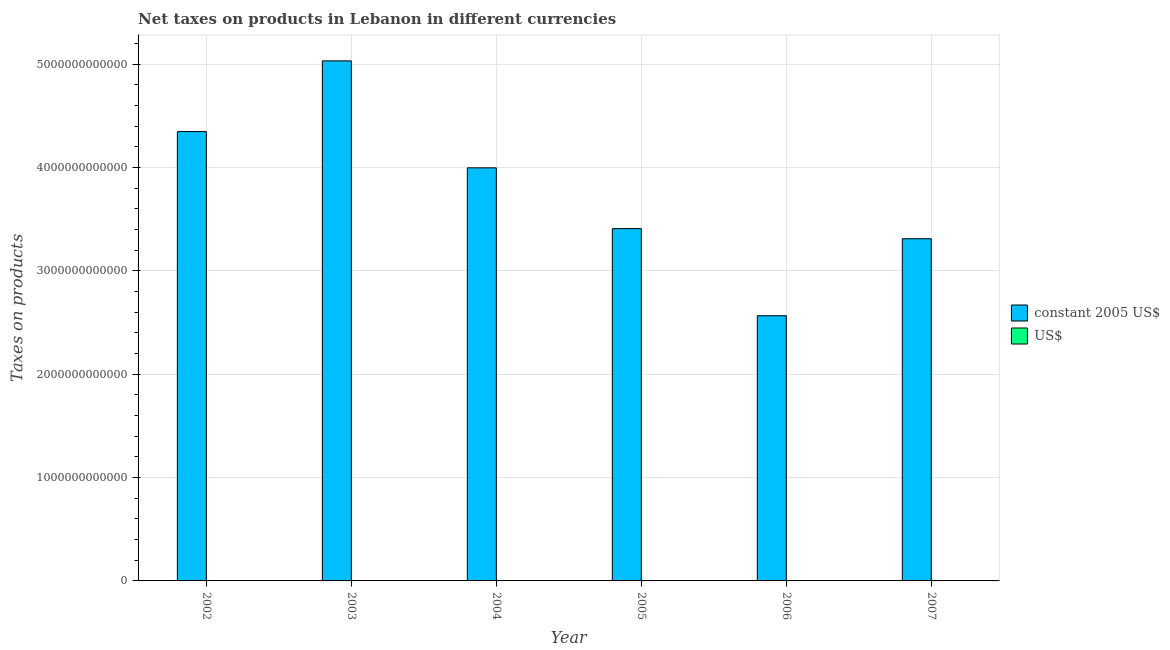Are the number of bars on each tick of the X-axis equal?
Ensure brevity in your answer.  Yes. How many bars are there on the 2nd tick from the left?
Make the answer very short. 2. What is the net taxes in us$ in 2004?
Ensure brevity in your answer.  2.65e+09. Across all years, what is the maximum net taxes in constant 2005 us$?
Give a very brief answer. 5.03e+12. Across all years, what is the minimum net taxes in us$?
Provide a succinct answer. 1.70e+09. In which year was the net taxes in us$ maximum?
Your response must be concise. 2003. What is the total net taxes in us$ in the graph?
Your response must be concise. 1.50e+1. What is the difference between the net taxes in constant 2005 us$ in 2002 and that in 2006?
Your answer should be very brief. 1.78e+12. What is the difference between the net taxes in constant 2005 us$ in 2005 and the net taxes in us$ in 2004?
Offer a very short reply. -5.88e+11. What is the average net taxes in constant 2005 us$ per year?
Your answer should be very brief. 3.78e+12. In the year 2006, what is the difference between the net taxes in constant 2005 us$ and net taxes in us$?
Offer a very short reply. 0. What is the ratio of the net taxes in constant 2005 us$ in 2003 to that in 2007?
Offer a terse response. 1.52. Is the difference between the net taxes in constant 2005 us$ in 2003 and 2007 greater than the difference between the net taxes in us$ in 2003 and 2007?
Your response must be concise. No. What is the difference between the highest and the second highest net taxes in constant 2005 us$?
Provide a short and direct response. 6.84e+11. What is the difference between the highest and the lowest net taxes in us$?
Provide a short and direct response. 1.64e+09. Is the sum of the net taxes in us$ in 2004 and 2006 greater than the maximum net taxes in constant 2005 us$ across all years?
Keep it short and to the point. Yes. What does the 2nd bar from the left in 2002 represents?
Offer a very short reply. US$. What does the 1st bar from the right in 2004 represents?
Your answer should be very brief. US$. Are all the bars in the graph horizontal?
Make the answer very short. No. What is the difference between two consecutive major ticks on the Y-axis?
Give a very brief answer. 1.00e+12. Does the graph contain grids?
Give a very brief answer. Yes. Where does the legend appear in the graph?
Provide a short and direct response. Center right. How are the legend labels stacked?
Your answer should be very brief. Vertical. What is the title of the graph?
Your response must be concise. Net taxes on products in Lebanon in different currencies. What is the label or title of the X-axis?
Offer a very short reply. Year. What is the label or title of the Y-axis?
Offer a very short reply. Taxes on products. What is the Taxes on products of constant 2005 US$ in 2002?
Keep it short and to the point. 4.35e+12. What is the Taxes on products in US$ in 2002?
Your answer should be very brief. 2.88e+09. What is the Taxes on products of constant 2005 US$ in 2003?
Your answer should be very brief. 5.03e+12. What is the Taxes on products in US$ in 2003?
Offer a very short reply. 3.34e+09. What is the Taxes on products in constant 2005 US$ in 2004?
Offer a very short reply. 4.00e+12. What is the Taxes on products in US$ in 2004?
Provide a short and direct response. 2.65e+09. What is the Taxes on products of constant 2005 US$ in 2005?
Give a very brief answer. 3.41e+12. What is the Taxes on products in US$ in 2005?
Offer a very short reply. 2.26e+09. What is the Taxes on products of constant 2005 US$ in 2006?
Provide a succinct answer. 2.57e+12. What is the Taxes on products in US$ in 2006?
Provide a succinct answer. 1.70e+09. What is the Taxes on products of constant 2005 US$ in 2007?
Provide a succinct answer. 3.31e+12. What is the Taxes on products of US$ in 2007?
Your answer should be compact. 2.20e+09. Across all years, what is the maximum Taxes on products in constant 2005 US$?
Your answer should be compact. 5.03e+12. Across all years, what is the maximum Taxes on products in US$?
Make the answer very short. 3.34e+09. Across all years, what is the minimum Taxes on products in constant 2005 US$?
Provide a short and direct response. 2.57e+12. Across all years, what is the minimum Taxes on products in US$?
Provide a short and direct response. 1.70e+09. What is the total Taxes on products in constant 2005 US$ in the graph?
Offer a very short reply. 2.27e+13. What is the total Taxes on products of US$ in the graph?
Make the answer very short. 1.50e+1. What is the difference between the Taxes on products of constant 2005 US$ in 2002 and that in 2003?
Ensure brevity in your answer.  -6.84e+11. What is the difference between the Taxes on products in US$ in 2002 and that in 2003?
Keep it short and to the point. -4.54e+08. What is the difference between the Taxes on products in constant 2005 US$ in 2002 and that in 2004?
Give a very brief answer. 3.51e+11. What is the difference between the Taxes on products in US$ in 2002 and that in 2004?
Give a very brief answer. 2.33e+08. What is the difference between the Taxes on products in constant 2005 US$ in 2002 and that in 2005?
Give a very brief answer. 9.39e+11. What is the difference between the Taxes on products in US$ in 2002 and that in 2005?
Offer a very short reply. 6.23e+08. What is the difference between the Taxes on products in constant 2005 US$ in 2002 and that in 2006?
Your answer should be very brief. 1.78e+12. What is the difference between the Taxes on products in US$ in 2002 and that in 2006?
Keep it short and to the point. 1.18e+09. What is the difference between the Taxes on products of constant 2005 US$ in 2002 and that in 2007?
Offer a very short reply. 1.04e+12. What is the difference between the Taxes on products in US$ in 2002 and that in 2007?
Your response must be concise. 6.88e+08. What is the difference between the Taxes on products of constant 2005 US$ in 2003 and that in 2004?
Offer a very short reply. 1.04e+12. What is the difference between the Taxes on products of US$ in 2003 and that in 2004?
Keep it short and to the point. 6.87e+08. What is the difference between the Taxes on products of constant 2005 US$ in 2003 and that in 2005?
Provide a succinct answer. 1.62e+12. What is the difference between the Taxes on products in US$ in 2003 and that in 2005?
Offer a terse response. 1.08e+09. What is the difference between the Taxes on products of constant 2005 US$ in 2003 and that in 2006?
Make the answer very short. 2.47e+12. What is the difference between the Taxes on products in US$ in 2003 and that in 2006?
Offer a terse response. 1.64e+09. What is the difference between the Taxes on products of constant 2005 US$ in 2003 and that in 2007?
Give a very brief answer. 1.72e+12. What is the difference between the Taxes on products in US$ in 2003 and that in 2007?
Offer a very short reply. 1.14e+09. What is the difference between the Taxes on products of constant 2005 US$ in 2004 and that in 2005?
Offer a terse response. 5.88e+11. What is the difference between the Taxes on products of US$ in 2004 and that in 2005?
Offer a very short reply. 3.90e+08. What is the difference between the Taxes on products of constant 2005 US$ in 2004 and that in 2006?
Ensure brevity in your answer.  1.43e+12. What is the difference between the Taxes on products of US$ in 2004 and that in 2006?
Make the answer very short. 9.49e+08. What is the difference between the Taxes on products in constant 2005 US$ in 2004 and that in 2007?
Keep it short and to the point. 6.86e+11. What is the difference between the Taxes on products of US$ in 2004 and that in 2007?
Provide a short and direct response. 4.55e+08. What is the difference between the Taxes on products of constant 2005 US$ in 2005 and that in 2006?
Make the answer very short. 8.43e+11. What is the difference between the Taxes on products of US$ in 2005 and that in 2006?
Provide a short and direct response. 5.59e+08. What is the difference between the Taxes on products of constant 2005 US$ in 2005 and that in 2007?
Your answer should be compact. 9.80e+1. What is the difference between the Taxes on products in US$ in 2005 and that in 2007?
Offer a terse response. 6.50e+07. What is the difference between the Taxes on products of constant 2005 US$ in 2006 and that in 2007?
Your answer should be very brief. -7.45e+11. What is the difference between the Taxes on products of US$ in 2006 and that in 2007?
Your answer should be compact. -4.94e+08. What is the difference between the Taxes on products in constant 2005 US$ in 2002 and the Taxes on products in US$ in 2003?
Provide a succinct answer. 4.34e+12. What is the difference between the Taxes on products in constant 2005 US$ in 2002 and the Taxes on products in US$ in 2004?
Offer a terse response. 4.35e+12. What is the difference between the Taxes on products in constant 2005 US$ in 2002 and the Taxes on products in US$ in 2005?
Provide a succinct answer. 4.35e+12. What is the difference between the Taxes on products of constant 2005 US$ in 2002 and the Taxes on products of US$ in 2006?
Make the answer very short. 4.35e+12. What is the difference between the Taxes on products in constant 2005 US$ in 2002 and the Taxes on products in US$ in 2007?
Offer a very short reply. 4.35e+12. What is the difference between the Taxes on products of constant 2005 US$ in 2003 and the Taxes on products of US$ in 2004?
Your response must be concise. 5.03e+12. What is the difference between the Taxes on products in constant 2005 US$ in 2003 and the Taxes on products in US$ in 2005?
Give a very brief answer. 5.03e+12. What is the difference between the Taxes on products in constant 2005 US$ in 2003 and the Taxes on products in US$ in 2006?
Offer a terse response. 5.03e+12. What is the difference between the Taxes on products of constant 2005 US$ in 2003 and the Taxes on products of US$ in 2007?
Your answer should be very brief. 5.03e+12. What is the difference between the Taxes on products of constant 2005 US$ in 2004 and the Taxes on products of US$ in 2005?
Your answer should be compact. 3.99e+12. What is the difference between the Taxes on products of constant 2005 US$ in 2004 and the Taxes on products of US$ in 2006?
Offer a very short reply. 4.00e+12. What is the difference between the Taxes on products of constant 2005 US$ in 2004 and the Taxes on products of US$ in 2007?
Your response must be concise. 3.99e+12. What is the difference between the Taxes on products in constant 2005 US$ in 2005 and the Taxes on products in US$ in 2006?
Make the answer very short. 3.41e+12. What is the difference between the Taxes on products of constant 2005 US$ in 2005 and the Taxes on products of US$ in 2007?
Ensure brevity in your answer.  3.41e+12. What is the difference between the Taxes on products of constant 2005 US$ in 2006 and the Taxes on products of US$ in 2007?
Ensure brevity in your answer.  2.56e+12. What is the average Taxes on products of constant 2005 US$ per year?
Offer a very short reply. 3.78e+12. What is the average Taxes on products of US$ per year?
Provide a succinct answer. 2.51e+09. In the year 2002, what is the difference between the Taxes on products in constant 2005 US$ and Taxes on products in US$?
Ensure brevity in your answer.  4.35e+12. In the year 2003, what is the difference between the Taxes on products of constant 2005 US$ and Taxes on products of US$?
Provide a short and direct response. 5.03e+12. In the year 2004, what is the difference between the Taxes on products of constant 2005 US$ and Taxes on products of US$?
Provide a short and direct response. 3.99e+12. In the year 2005, what is the difference between the Taxes on products in constant 2005 US$ and Taxes on products in US$?
Offer a very short reply. 3.41e+12. In the year 2006, what is the difference between the Taxes on products of constant 2005 US$ and Taxes on products of US$?
Provide a succinct answer. 2.56e+12. In the year 2007, what is the difference between the Taxes on products of constant 2005 US$ and Taxes on products of US$?
Your answer should be very brief. 3.31e+12. What is the ratio of the Taxes on products in constant 2005 US$ in 2002 to that in 2003?
Provide a short and direct response. 0.86. What is the ratio of the Taxes on products in US$ in 2002 to that in 2003?
Offer a very short reply. 0.86. What is the ratio of the Taxes on products of constant 2005 US$ in 2002 to that in 2004?
Your answer should be compact. 1.09. What is the ratio of the Taxes on products of US$ in 2002 to that in 2004?
Give a very brief answer. 1.09. What is the ratio of the Taxes on products of constant 2005 US$ in 2002 to that in 2005?
Give a very brief answer. 1.28. What is the ratio of the Taxes on products in US$ in 2002 to that in 2005?
Keep it short and to the point. 1.28. What is the ratio of the Taxes on products in constant 2005 US$ in 2002 to that in 2006?
Your answer should be very brief. 1.69. What is the ratio of the Taxes on products in US$ in 2002 to that in 2006?
Your response must be concise. 1.69. What is the ratio of the Taxes on products of constant 2005 US$ in 2002 to that in 2007?
Provide a succinct answer. 1.31. What is the ratio of the Taxes on products of US$ in 2002 to that in 2007?
Your answer should be very brief. 1.31. What is the ratio of the Taxes on products in constant 2005 US$ in 2003 to that in 2004?
Keep it short and to the point. 1.26. What is the ratio of the Taxes on products in US$ in 2003 to that in 2004?
Your answer should be compact. 1.26. What is the ratio of the Taxes on products in constant 2005 US$ in 2003 to that in 2005?
Your response must be concise. 1.48. What is the ratio of the Taxes on products in US$ in 2003 to that in 2005?
Ensure brevity in your answer.  1.48. What is the ratio of the Taxes on products of constant 2005 US$ in 2003 to that in 2006?
Your answer should be very brief. 1.96. What is the ratio of the Taxes on products in US$ in 2003 to that in 2006?
Give a very brief answer. 1.96. What is the ratio of the Taxes on products of constant 2005 US$ in 2003 to that in 2007?
Make the answer very short. 1.52. What is the ratio of the Taxes on products of US$ in 2003 to that in 2007?
Make the answer very short. 1.52. What is the ratio of the Taxes on products in constant 2005 US$ in 2004 to that in 2005?
Make the answer very short. 1.17. What is the ratio of the Taxes on products in US$ in 2004 to that in 2005?
Keep it short and to the point. 1.17. What is the ratio of the Taxes on products in constant 2005 US$ in 2004 to that in 2006?
Provide a short and direct response. 1.56. What is the ratio of the Taxes on products of US$ in 2004 to that in 2006?
Provide a short and direct response. 1.56. What is the ratio of the Taxes on products of constant 2005 US$ in 2004 to that in 2007?
Provide a short and direct response. 1.21. What is the ratio of the Taxes on products in US$ in 2004 to that in 2007?
Offer a very short reply. 1.21. What is the ratio of the Taxes on products in constant 2005 US$ in 2005 to that in 2006?
Provide a short and direct response. 1.33. What is the ratio of the Taxes on products in US$ in 2005 to that in 2006?
Offer a very short reply. 1.33. What is the ratio of the Taxes on products in constant 2005 US$ in 2005 to that in 2007?
Provide a succinct answer. 1.03. What is the ratio of the Taxes on products of US$ in 2005 to that in 2007?
Make the answer very short. 1.03. What is the ratio of the Taxes on products of constant 2005 US$ in 2006 to that in 2007?
Offer a very short reply. 0.78. What is the ratio of the Taxes on products in US$ in 2006 to that in 2007?
Ensure brevity in your answer.  0.78. What is the difference between the highest and the second highest Taxes on products in constant 2005 US$?
Make the answer very short. 6.84e+11. What is the difference between the highest and the second highest Taxes on products in US$?
Keep it short and to the point. 4.54e+08. What is the difference between the highest and the lowest Taxes on products in constant 2005 US$?
Provide a succinct answer. 2.47e+12. What is the difference between the highest and the lowest Taxes on products in US$?
Your answer should be compact. 1.64e+09. 